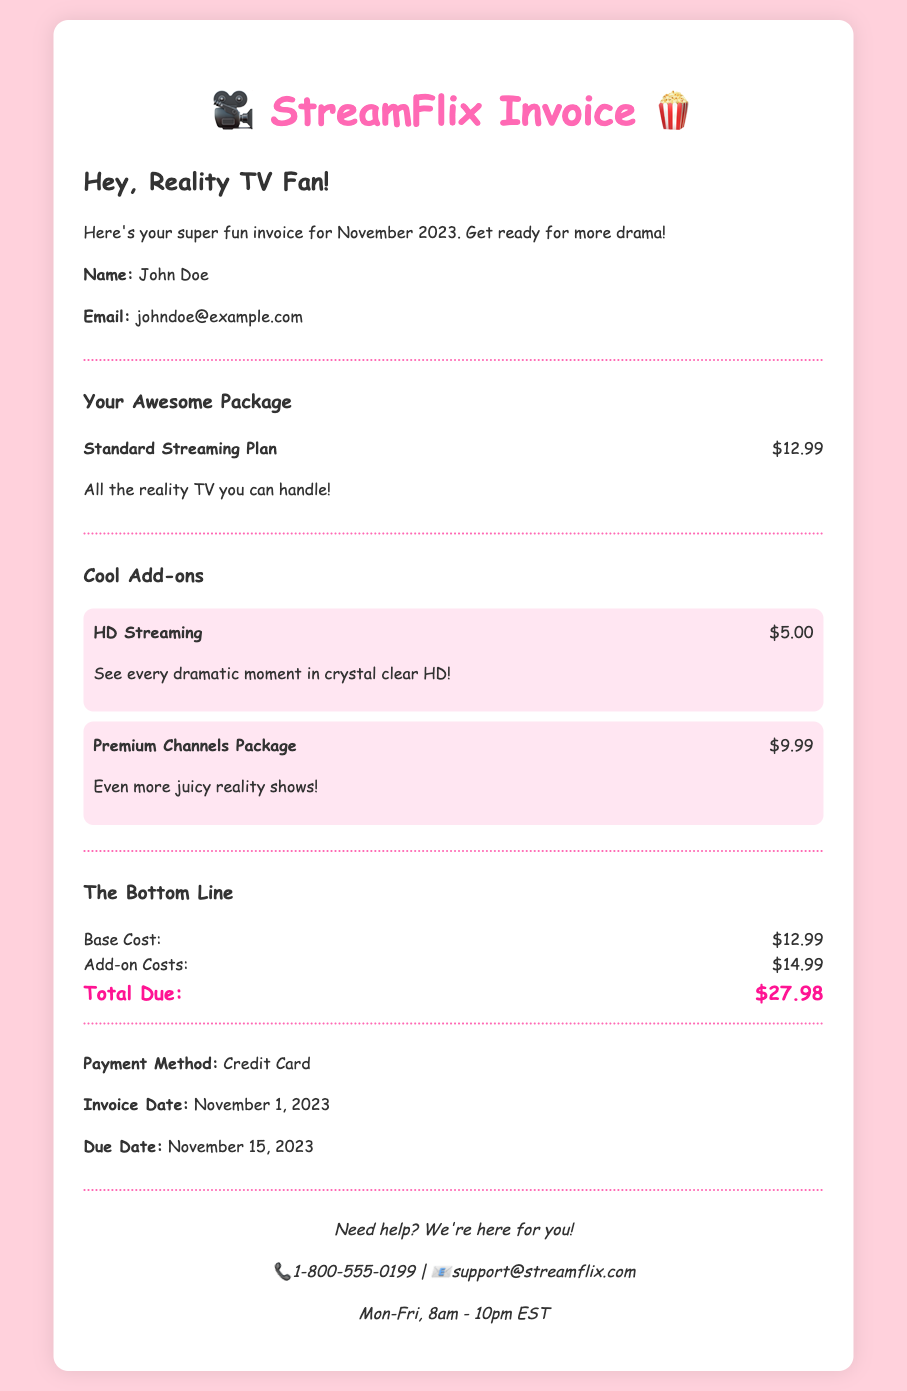What is the name on the invoice? The name is clearly stated in the document under customer details.
Answer: John Doe What is the total due amount? The total due is calculated from the base cost and add-on costs presented in the document.
Answer: $27.98 What is the cost of the Standard Streaming Plan? The document lists the cost of the Standard Streaming Plan separately.
Answer: $12.99 How much is the HD Streaming add-on? The document explicitly states the cost of the HD Streaming add-on in the add-ons section.
Answer: $5.00 When is the due date for this invoice? The due date is mentioned near the payment details in the document.
Answer: November 15, 2023 How much do the add-ons cost in total? The total add-ons cost is derived from the individual add-on prices listed in the document.
Answer: $14.99 What payment method was used? The payment method is explicitly noted in the payment details section.
Answer: Credit Card What was the invoice date? The invoice date is mentioned along with the payment method and due date.
Answer: November 1, 2023 What is included in the Premium Channels Package add-on? The description for the Premium Channels Package provides insight into what it includes.
Answer: Even more juicy reality shows! 